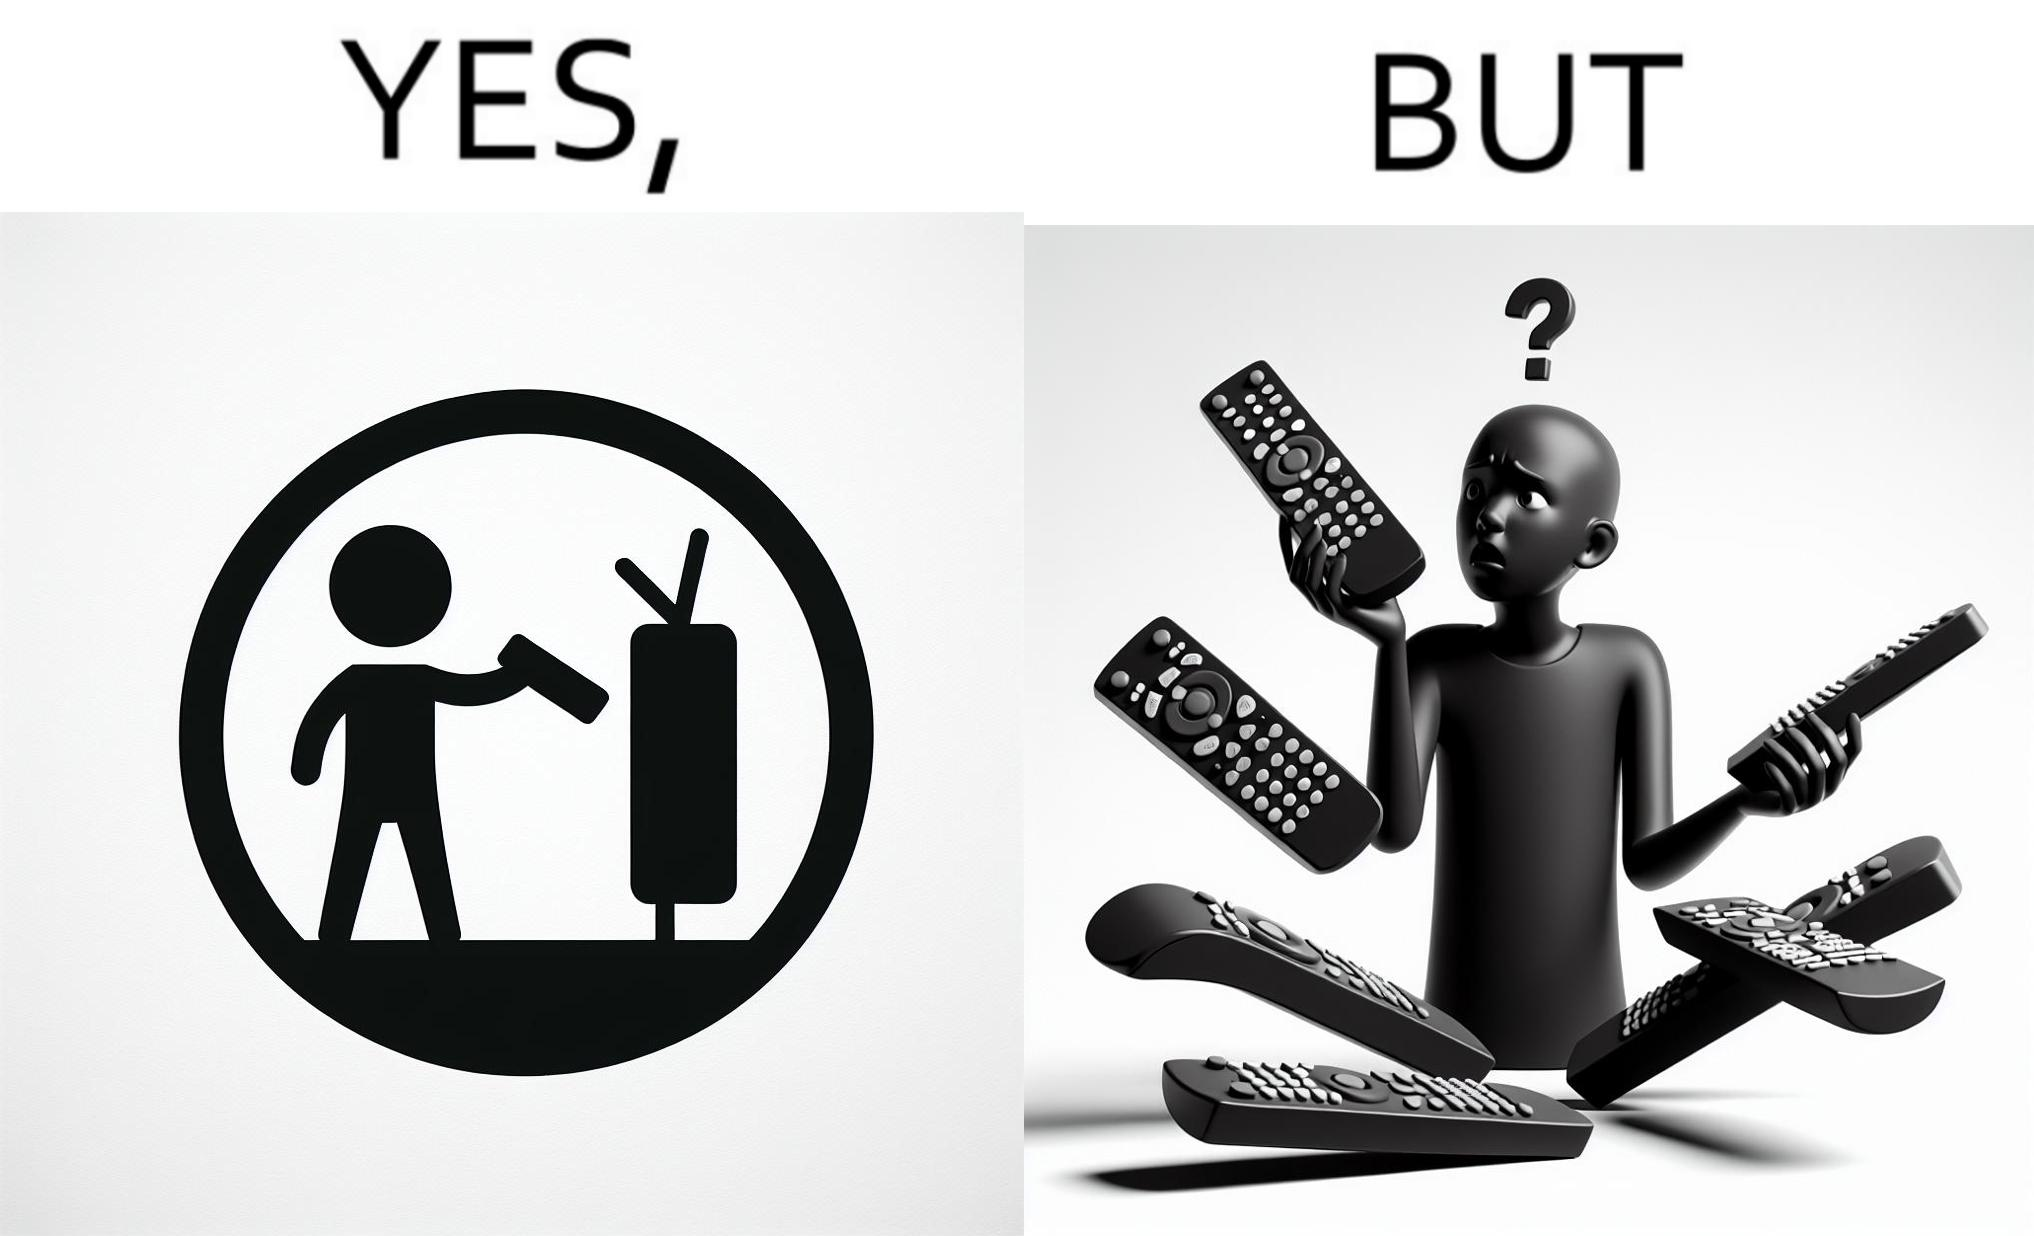Would you classify this image as satirical? Yes, this image is satirical. 